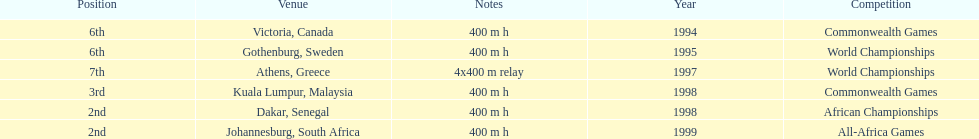In what years did ken harnden do better that 5th place? 1998, 1999. 